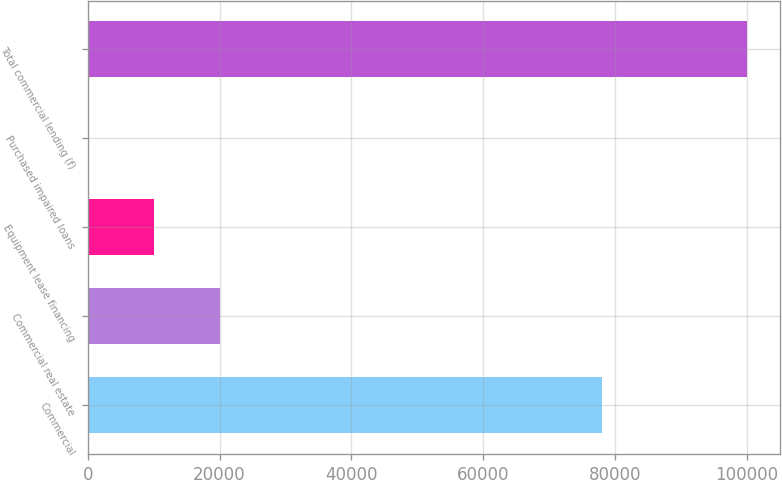<chart> <loc_0><loc_0><loc_500><loc_500><bar_chart><fcel>Commercial<fcel>Commercial real estate<fcel>Equipment lease financing<fcel>Purchased impaired loans<fcel>Total commercial lending (f)<nl><fcel>78048<fcel>20050.6<fcel>10049.8<fcel>49<fcel>100057<nl></chart> 